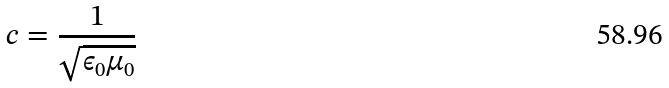Convert formula to latex. <formula><loc_0><loc_0><loc_500><loc_500>c = \frac { 1 } { \sqrt { \epsilon _ { 0 } \mu _ { 0 } } }</formula> 